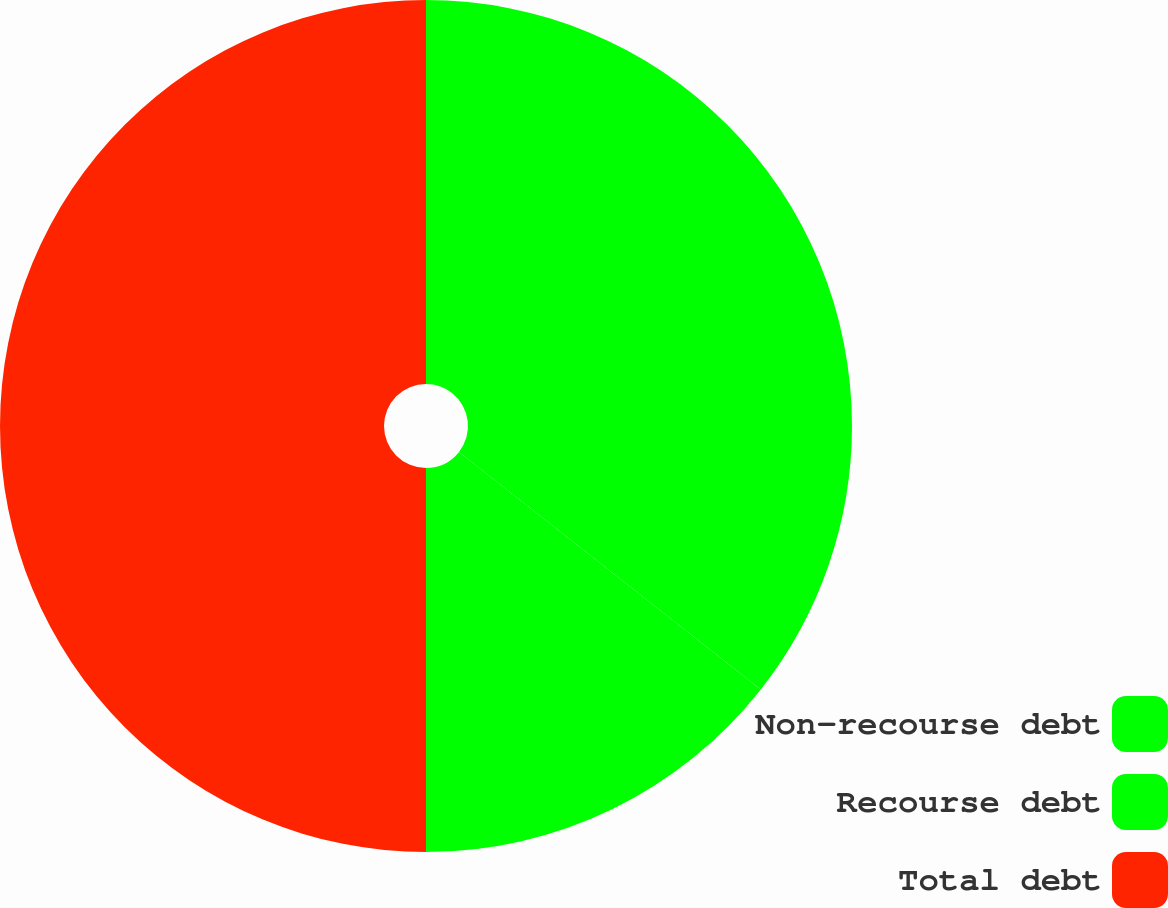Convert chart. <chart><loc_0><loc_0><loc_500><loc_500><pie_chart><fcel>Non-recourse debt<fcel>Recourse debt<fcel>Total debt<nl><fcel>35.61%<fcel>14.39%<fcel>50.0%<nl></chart> 